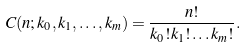<formula> <loc_0><loc_0><loc_500><loc_500>C ( n ; k _ { 0 } , k _ { 1 } , \dots , k _ { m } ) = \frac { n ! } { k _ { 0 } ! k _ { 1 } ! \dots k _ { m } ! } .</formula> 